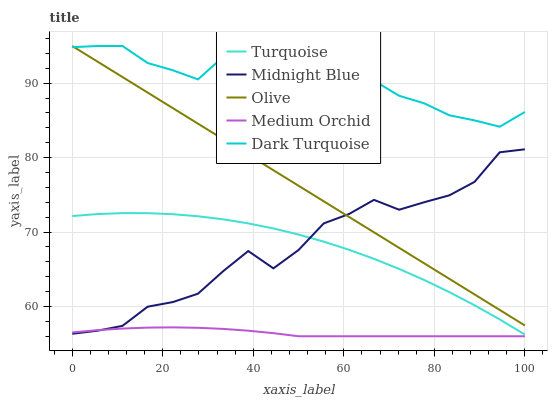Does Medium Orchid have the minimum area under the curve?
Answer yes or no. Yes. Does Dark Turquoise have the maximum area under the curve?
Answer yes or no. Yes. Does Turquoise have the minimum area under the curve?
Answer yes or no. No. Does Turquoise have the maximum area under the curve?
Answer yes or no. No. Is Olive the smoothest?
Answer yes or no. Yes. Is Dark Turquoise the roughest?
Answer yes or no. Yes. Is Turquoise the smoothest?
Answer yes or no. No. Is Turquoise the roughest?
Answer yes or no. No. Does Medium Orchid have the lowest value?
Answer yes or no. Yes. Does Turquoise have the lowest value?
Answer yes or no. No. Does Dark Turquoise have the highest value?
Answer yes or no. Yes. Does Turquoise have the highest value?
Answer yes or no. No. Is Turquoise less than Olive?
Answer yes or no. Yes. Is Dark Turquoise greater than Midnight Blue?
Answer yes or no. Yes. Does Midnight Blue intersect Olive?
Answer yes or no. Yes. Is Midnight Blue less than Olive?
Answer yes or no. No. Is Midnight Blue greater than Olive?
Answer yes or no. No. Does Turquoise intersect Olive?
Answer yes or no. No. 